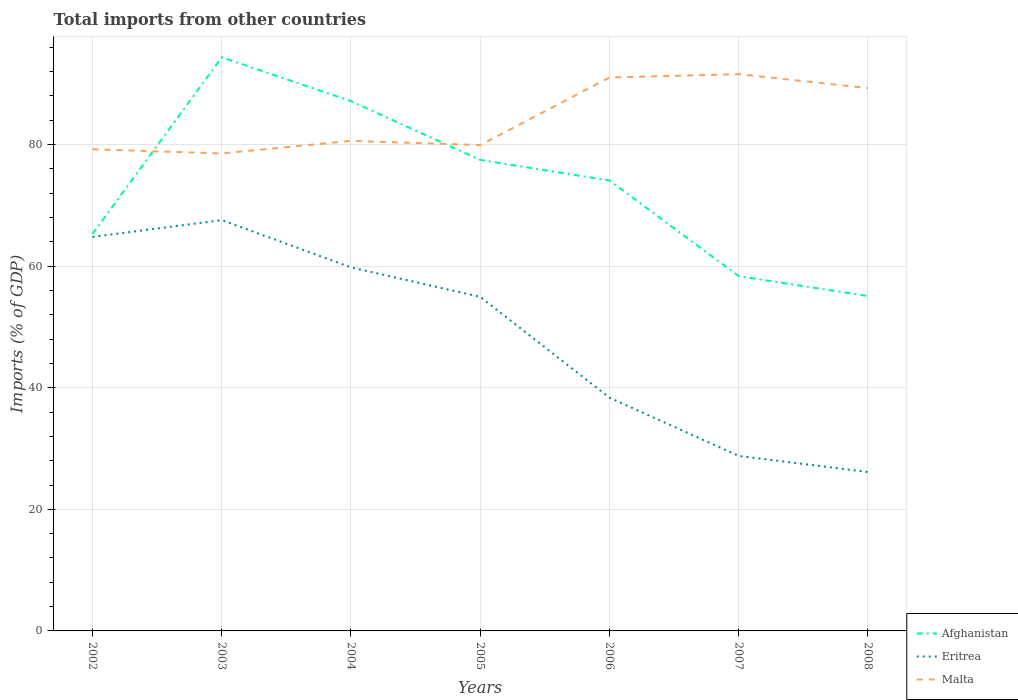How many different coloured lines are there?
Ensure brevity in your answer.  3. Does the line corresponding to Malta intersect with the line corresponding to Afghanistan?
Make the answer very short. Yes. Is the number of lines equal to the number of legend labels?
Give a very brief answer. Yes. Across all years, what is the maximum total imports in Afghanistan?
Provide a short and direct response. 55.07. What is the total total imports in Malta in the graph?
Your response must be concise. -1.37. What is the difference between the highest and the second highest total imports in Eritrea?
Offer a very short reply. 41.43. What is the difference between the highest and the lowest total imports in Malta?
Provide a short and direct response. 3. Is the total imports in Afghanistan strictly greater than the total imports in Eritrea over the years?
Keep it short and to the point. No. What is the difference between two consecutive major ticks on the Y-axis?
Your answer should be compact. 20. Are the values on the major ticks of Y-axis written in scientific E-notation?
Keep it short and to the point. No. Does the graph contain any zero values?
Your answer should be compact. No. Where does the legend appear in the graph?
Give a very brief answer. Bottom right. How many legend labels are there?
Provide a succinct answer. 3. What is the title of the graph?
Give a very brief answer. Total imports from other countries. Does "Zambia" appear as one of the legend labels in the graph?
Give a very brief answer. No. What is the label or title of the X-axis?
Your answer should be compact. Years. What is the label or title of the Y-axis?
Give a very brief answer. Imports (% of GDP). What is the Imports (% of GDP) in Afghanistan in 2002?
Your response must be concise. 65.29. What is the Imports (% of GDP) of Eritrea in 2002?
Provide a succinct answer. 64.81. What is the Imports (% of GDP) of Malta in 2002?
Give a very brief answer. 79.22. What is the Imports (% of GDP) in Afghanistan in 2003?
Provide a succinct answer. 94.34. What is the Imports (% of GDP) in Eritrea in 2003?
Your answer should be very brief. 67.57. What is the Imports (% of GDP) of Malta in 2003?
Provide a succinct answer. 78.53. What is the Imports (% of GDP) in Afghanistan in 2004?
Your answer should be very brief. 87.14. What is the Imports (% of GDP) in Eritrea in 2004?
Ensure brevity in your answer.  59.8. What is the Imports (% of GDP) in Malta in 2004?
Your answer should be very brief. 80.6. What is the Imports (% of GDP) in Afghanistan in 2005?
Your answer should be very brief. 77.47. What is the Imports (% of GDP) of Eritrea in 2005?
Ensure brevity in your answer.  54.94. What is the Imports (% of GDP) of Malta in 2005?
Offer a terse response. 79.91. What is the Imports (% of GDP) in Afghanistan in 2006?
Offer a terse response. 74.09. What is the Imports (% of GDP) in Eritrea in 2006?
Provide a succinct answer. 38.36. What is the Imports (% of GDP) of Malta in 2006?
Offer a terse response. 91.02. What is the Imports (% of GDP) in Afghanistan in 2007?
Your response must be concise. 58.35. What is the Imports (% of GDP) in Eritrea in 2007?
Keep it short and to the point. 28.79. What is the Imports (% of GDP) of Malta in 2007?
Provide a succinct answer. 91.57. What is the Imports (% of GDP) of Afghanistan in 2008?
Provide a succinct answer. 55.07. What is the Imports (% of GDP) in Eritrea in 2008?
Your answer should be compact. 26.13. What is the Imports (% of GDP) of Malta in 2008?
Offer a terse response. 89.28. Across all years, what is the maximum Imports (% of GDP) of Afghanistan?
Offer a terse response. 94.34. Across all years, what is the maximum Imports (% of GDP) of Eritrea?
Offer a very short reply. 67.57. Across all years, what is the maximum Imports (% of GDP) in Malta?
Keep it short and to the point. 91.57. Across all years, what is the minimum Imports (% of GDP) of Afghanistan?
Your answer should be very brief. 55.07. Across all years, what is the minimum Imports (% of GDP) in Eritrea?
Your answer should be very brief. 26.13. Across all years, what is the minimum Imports (% of GDP) of Malta?
Keep it short and to the point. 78.53. What is the total Imports (% of GDP) of Afghanistan in the graph?
Offer a terse response. 511.75. What is the total Imports (% of GDP) in Eritrea in the graph?
Your answer should be compact. 340.39. What is the total Imports (% of GDP) in Malta in the graph?
Offer a very short reply. 590.14. What is the difference between the Imports (% of GDP) in Afghanistan in 2002 and that in 2003?
Your response must be concise. -29.06. What is the difference between the Imports (% of GDP) of Eritrea in 2002 and that in 2003?
Ensure brevity in your answer.  -2.76. What is the difference between the Imports (% of GDP) of Malta in 2002 and that in 2003?
Your answer should be very brief. 0.69. What is the difference between the Imports (% of GDP) of Afghanistan in 2002 and that in 2004?
Keep it short and to the point. -21.85. What is the difference between the Imports (% of GDP) of Eritrea in 2002 and that in 2004?
Provide a short and direct response. 5.01. What is the difference between the Imports (% of GDP) of Malta in 2002 and that in 2004?
Keep it short and to the point. -1.38. What is the difference between the Imports (% of GDP) of Afghanistan in 2002 and that in 2005?
Provide a short and direct response. -12.18. What is the difference between the Imports (% of GDP) in Eritrea in 2002 and that in 2005?
Ensure brevity in your answer.  9.87. What is the difference between the Imports (% of GDP) in Malta in 2002 and that in 2005?
Your answer should be very brief. -0.69. What is the difference between the Imports (% of GDP) in Afghanistan in 2002 and that in 2006?
Provide a short and direct response. -8.8. What is the difference between the Imports (% of GDP) in Eritrea in 2002 and that in 2006?
Provide a succinct answer. 26.45. What is the difference between the Imports (% of GDP) of Malta in 2002 and that in 2006?
Ensure brevity in your answer.  -11.8. What is the difference between the Imports (% of GDP) in Afghanistan in 2002 and that in 2007?
Offer a very short reply. 6.94. What is the difference between the Imports (% of GDP) of Eritrea in 2002 and that in 2007?
Ensure brevity in your answer.  36.02. What is the difference between the Imports (% of GDP) in Malta in 2002 and that in 2007?
Give a very brief answer. -12.35. What is the difference between the Imports (% of GDP) of Afghanistan in 2002 and that in 2008?
Keep it short and to the point. 10.22. What is the difference between the Imports (% of GDP) of Eritrea in 2002 and that in 2008?
Provide a short and direct response. 38.68. What is the difference between the Imports (% of GDP) of Malta in 2002 and that in 2008?
Provide a short and direct response. -10.06. What is the difference between the Imports (% of GDP) of Afghanistan in 2003 and that in 2004?
Your response must be concise. 7.2. What is the difference between the Imports (% of GDP) in Eritrea in 2003 and that in 2004?
Offer a very short reply. 7.77. What is the difference between the Imports (% of GDP) of Malta in 2003 and that in 2004?
Ensure brevity in your answer.  -2.07. What is the difference between the Imports (% of GDP) of Afghanistan in 2003 and that in 2005?
Offer a terse response. 16.88. What is the difference between the Imports (% of GDP) of Eritrea in 2003 and that in 2005?
Make the answer very short. 12.63. What is the difference between the Imports (% of GDP) of Malta in 2003 and that in 2005?
Keep it short and to the point. -1.37. What is the difference between the Imports (% of GDP) in Afghanistan in 2003 and that in 2006?
Your response must be concise. 20.26. What is the difference between the Imports (% of GDP) of Eritrea in 2003 and that in 2006?
Keep it short and to the point. 29.2. What is the difference between the Imports (% of GDP) in Malta in 2003 and that in 2006?
Offer a terse response. -12.49. What is the difference between the Imports (% of GDP) in Afghanistan in 2003 and that in 2007?
Your answer should be very brief. 35.99. What is the difference between the Imports (% of GDP) of Eritrea in 2003 and that in 2007?
Provide a succinct answer. 38.78. What is the difference between the Imports (% of GDP) of Malta in 2003 and that in 2007?
Your response must be concise. -13.04. What is the difference between the Imports (% of GDP) in Afghanistan in 2003 and that in 2008?
Your answer should be compact. 39.27. What is the difference between the Imports (% of GDP) of Eritrea in 2003 and that in 2008?
Your response must be concise. 41.43. What is the difference between the Imports (% of GDP) in Malta in 2003 and that in 2008?
Offer a very short reply. -10.75. What is the difference between the Imports (% of GDP) of Afghanistan in 2004 and that in 2005?
Make the answer very short. 9.67. What is the difference between the Imports (% of GDP) of Eritrea in 2004 and that in 2005?
Your answer should be very brief. 4.86. What is the difference between the Imports (% of GDP) of Malta in 2004 and that in 2005?
Keep it short and to the point. 0.69. What is the difference between the Imports (% of GDP) in Afghanistan in 2004 and that in 2006?
Your response must be concise. 13.05. What is the difference between the Imports (% of GDP) in Eritrea in 2004 and that in 2006?
Make the answer very short. 21.43. What is the difference between the Imports (% of GDP) in Malta in 2004 and that in 2006?
Your response must be concise. -10.42. What is the difference between the Imports (% of GDP) of Afghanistan in 2004 and that in 2007?
Keep it short and to the point. 28.79. What is the difference between the Imports (% of GDP) of Eritrea in 2004 and that in 2007?
Keep it short and to the point. 31.01. What is the difference between the Imports (% of GDP) of Malta in 2004 and that in 2007?
Ensure brevity in your answer.  -10.97. What is the difference between the Imports (% of GDP) in Afghanistan in 2004 and that in 2008?
Offer a terse response. 32.07. What is the difference between the Imports (% of GDP) of Eritrea in 2004 and that in 2008?
Make the answer very short. 33.66. What is the difference between the Imports (% of GDP) in Malta in 2004 and that in 2008?
Offer a very short reply. -8.68. What is the difference between the Imports (% of GDP) of Afghanistan in 2005 and that in 2006?
Keep it short and to the point. 3.38. What is the difference between the Imports (% of GDP) of Eritrea in 2005 and that in 2006?
Give a very brief answer. 16.58. What is the difference between the Imports (% of GDP) of Malta in 2005 and that in 2006?
Offer a very short reply. -11.11. What is the difference between the Imports (% of GDP) in Afghanistan in 2005 and that in 2007?
Your answer should be very brief. 19.12. What is the difference between the Imports (% of GDP) in Eritrea in 2005 and that in 2007?
Ensure brevity in your answer.  26.15. What is the difference between the Imports (% of GDP) in Malta in 2005 and that in 2007?
Offer a very short reply. -11.67. What is the difference between the Imports (% of GDP) of Afghanistan in 2005 and that in 2008?
Your answer should be compact. 22.39. What is the difference between the Imports (% of GDP) of Eritrea in 2005 and that in 2008?
Give a very brief answer. 28.81. What is the difference between the Imports (% of GDP) of Malta in 2005 and that in 2008?
Give a very brief answer. -9.37. What is the difference between the Imports (% of GDP) in Afghanistan in 2006 and that in 2007?
Offer a very short reply. 15.73. What is the difference between the Imports (% of GDP) in Eritrea in 2006 and that in 2007?
Your answer should be compact. 9.57. What is the difference between the Imports (% of GDP) of Malta in 2006 and that in 2007?
Offer a very short reply. -0.55. What is the difference between the Imports (% of GDP) in Afghanistan in 2006 and that in 2008?
Provide a short and direct response. 19.01. What is the difference between the Imports (% of GDP) of Eritrea in 2006 and that in 2008?
Keep it short and to the point. 12.23. What is the difference between the Imports (% of GDP) of Malta in 2006 and that in 2008?
Your answer should be very brief. 1.74. What is the difference between the Imports (% of GDP) of Afghanistan in 2007 and that in 2008?
Give a very brief answer. 3.28. What is the difference between the Imports (% of GDP) of Eritrea in 2007 and that in 2008?
Give a very brief answer. 2.66. What is the difference between the Imports (% of GDP) in Malta in 2007 and that in 2008?
Your response must be concise. 2.29. What is the difference between the Imports (% of GDP) in Afghanistan in 2002 and the Imports (% of GDP) in Eritrea in 2003?
Give a very brief answer. -2.28. What is the difference between the Imports (% of GDP) in Afghanistan in 2002 and the Imports (% of GDP) in Malta in 2003?
Give a very brief answer. -13.25. What is the difference between the Imports (% of GDP) of Eritrea in 2002 and the Imports (% of GDP) of Malta in 2003?
Provide a short and direct response. -13.72. What is the difference between the Imports (% of GDP) in Afghanistan in 2002 and the Imports (% of GDP) in Eritrea in 2004?
Make the answer very short. 5.49. What is the difference between the Imports (% of GDP) of Afghanistan in 2002 and the Imports (% of GDP) of Malta in 2004?
Provide a short and direct response. -15.31. What is the difference between the Imports (% of GDP) of Eritrea in 2002 and the Imports (% of GDP) of Malta in 2004?
Your answer should be very brief. -15.79. What is the difference between the Imports (% of GDP) of Afghanistan in 2002 and the Imports (% of GDP) of Eritrea in 2005?
Offer a terse response. 10.35. What is the difference between the Imports (% of GDP) of Afghanistan in 2002 and the Imports (% of GDP) of Malta in 2005?
Ensure brevity in your answer.  -14.62. What is the difference between the Imports (% of GDP) in Eritrea in 2002 and the Imports (% of GDP) in Malta in 2005?
Offer a very short reply. -15.1. What is the difference between the Imports (% of GDP) in Afghanistan in 2002 and the Imports (% of GDP) in Eritrea in 2006?
Your answer should be very brief. 26.93. What is the difference between the Imports (% of GDP) in Afghanistan in 2002 and the Imports (% of GDP) in Malta in 2006?
Offer a very short reply. -25.73. What is the difference between the Imports (% of GDP) of Eritrea in 2002 and the Imports (% of GDP) of Malta in 2006?
Provide a succinct answer. -26.21. What is the difference between the Imports (% of GDP) of Afghanistan in 2002 and the Imports (% of GDP) of Eritrea in 2007?
Provide a succinct answer. 36.5. What is the difference between the Imports (% of GDP) in Afghanistan in 2002 and the Imports (% of GDP) in Malta in 2007?
Your response must be concise. -26.29. What is the difference between the Imports (% of GDP) in Eritrea in 2002 and the Imports (% of GDP) in Malta in 2007?
Ensure brevity in your answer.  -26.77. What is the difference between the Imports (% of GDP) in Afghanistan in 2002 and the Imports (% of GDP) in Eritrea in 2008?
Your answer should be very brief. 39.16. What is the difference between the Imports (% of GDP) in Afghanistan in 2002 and the Imports (% of GDP) in Malta in 2008?
Offer a terse response. -23.99. What is the difference between the Imports (% of GDP) in Eritrea in 2002 and the Imports (% of GDP) in Malta in 2008?
Keep it short and to the point. -24.47. What is the difference between the Imports (% of GDP) in Afghanistan in 2003 and the Imports (% of GDP) in Eritrea in 2004?
Keep it short and to the point. 34.55. What is the difference between the Imports (% of GDP) in Afghanistan in 2003 and the Imports (% of GDP) in Malta in 2004?
Your answer should be very brief. 13.74. What is the difference between the Imports (% of GDP) of Eritrea in 2003 and the Imports (% of GDP) of Malta in 2004?
Your answer should be compact. -13.03. What is the difference between the Imports (% of GDP) of Afghanistan in 2003 and the Imports (% of GDP) of Eritrea in 2005?
Make the answer very short. 39.4. What is the difference between the Imports (% of GDP) of Afghanistan in 2003 and the Imports (% of GDP) of Malta in 2005?
Make the answer very short. 14.44. What is the difference between the Imports (% of GDP) in Eritrea in 2003 and the Imports (% of GDP) in Malta in 2005?
Offer a terse response. -12.34. What is the difference between the Imports (% of GDP) in Afghanistan in 2003 and the Imports (% of GDP) in Eritrea in 2006?
Provide a succinct answer. 55.98. What is the difference between the Imports (% of GDP) in Afghanistan in 2003 and the Imports (% of GDP) in Malta in 2006?
Keep it short and to the point. 3.32. What is the difference between the Imports (% of GDP) in Eritrea in 2003 and the Imports (% of GDP) in Malta in 2006?
Provide a short and direct response. -23.46. What is the difference between the Imports (% of GDP) of Afghanistan in 2003 and the Imports (% of GDP) of Eritrea in 2007?
Your response must be concise. 65.56. What is the difference between the Imports (% of GDP) of Afghanistan in 2003 and the Imports (% of GDP) of Malta in 2007?
Give a very brief answer. 2.77. What is the difference between the Imports (% of GDP) in Eritrea in 2003 and the Imports (% of GDP) in Malta in 2007?
Keep it short and to the point. -24.01. What is the difference between the Imports (% of GDP) in Afghanistan in 2003 and the Imports (% of GDP) in Eritrea in 2008?
Offer a very short reply. 68.21. What is the difference between the Imports (% of GDP) in Afghanistan in 2003 and the Imports (% of GDP) in Malta in 2008?
Offer a very short reply. 5.06. What is the difference between the Imports (% of GDP) of Eritrea in 2003 and the Imports (% of GDP) of Malta in 2008?
Provide a short and direct response. -21.71. What is the difference between the Imports (% of GDP) of Afghanistan in 2004 and the Imports (% of GDP) of Eritrea in 2005?
Offer a very short reply. 32.2. What is the difference between the Imports (% of GDP) in Afghanistan in 2004 and the Imports (% of GDP) in Malta in 2005?
Your answer should be compact. 7.23. What is the difference between the Imports (% of GDP) in Eritrea in 2004 and the Imports (% of GDP) in Malta in 2005?
Provide a short and direct response. -20.11. What is the difference between the Imports (% of GDP) in Afghanistan in 2004 and the Imports (% of GDP) in Eritrea in 2006?
Your answer should be very brief. 48.78. What is the difference between the Imports (% of GDP) of Afghanistan in 2004 and the Imports (% of GDP) of Malta in 2006?
Offer a very short reply. -3.88. What is the difference between the Imports (% of GDP) of Eritrea in 2004 and the Imports (% of GDP) of Malta in 2006?
Your answer should be compact. -31.23. What is the difference between the Imports (% of GDP) in Afghanistan in 2004 and the Imports (% of GDP) in Eritrea in 2007?
Make the answer very short. 58.35. What is the difference between the Imports (% of GDP) in Afghanistan in 2004 and the Imports (% of GDP) in Malta in 2007?
Offer a terse response. -4.44. What is the difference between the Imports (% of GDP) of Eritrea in 2004 and the Imports (% of GDP) of Malta in 2007?
Give a very brief answer. -31.78. What is the difference between the Imports (% of GDP) of Afghanistan in 2004 and the Imports (% of GDP) of Eritrea in 2008?
Your answer should be compact. 61.01. What is the difference between the Imports (% of GDP) in Afghanistan in 2004 and the Imports (% of GDP) in Malta in 2008?
Offer a very short reply. -2.14. What is the difference between the Imports (% of GDP) in Eritrea in 2004 and the Imports (% of GDP) in Malta in 2008?
Keep it short and to the point. -29.48. What is the difference between the Imports (% of GDP) of Afghanistan in 2005 and the Imports (% of GDP) of Eritrea in 2006?
Make the answer very short. 39.11. What is the difference between the Imports (% of GDP) in Afghanistan in 2005 and the Imports (% of GDP) in Malta in 2006?
Keep it short and to the point. -13.55. What is the difference between the Imports (% of GDP) in Eritrea in 2005 and the Imports (% of GDP) in Malta in 2006?
Offer a very short reply. -36.08. What is the difference between the Imports (% of GDP) in Afghanistan in 2005 and the Imports (% of GDP) in Eritrea in 2007?
Keep it short and to the point. 48.68. What is the difference between the Imports (% of GDP) of Afghanistan in 2005 and the Imports (% of GDP) of Malta in 2007?
Your response must be concise. -14.11. What is the difference between the Imports (% of GDP) of Eritrea in 2005 and the Imports (% of GDP) of Malta in 2007?
Make the answer very short. -36.63. What is the difference between the Imports (% of GDP) in Afghanistan in 2005 and the Imports (% of GDP) in Eritrea in 2008?
Offer a very short reply. 51.34. What is the difference between the Imports (% of GDP) of Afghanistan in 2005 and the Imports (% of GDP) of Malta in 2008?
Provide a succinct answer. -11.81. What is the difference between the Imports (% of GDP) of Eritrea in 2005 and the Imports (% of GDP) of Malta in 2008?
Your answer should be compact. -34.34. What is the difference between the Imports (% of GDP) of Afghanistan in 2006 and the Imports (% of GDP) of Eritrea in 2007?
Your response must be concise. 45.3. What is the difference between the Imports (% of GDP) in Afghanistan in 2006 and the Imports (% of GDP) in Malta in 2007?
Offer a very short reply. -17.49. What is the difference between the Imports (% of GDP) of Eritrea in 2006 and the Imports (% of GDP) of Malta in 2007?
Keep it short and to the point. -53.21. What is the difference between the Imports (% of GDP) in Afghanistan in 2006 and the Imports (% of GDP) in Eritrea in 2008?
Keep it short and to the point. 47.95. What is the difference between the Imports (% of GDP) of Afghanistan in 2006 and the Imports (% of GDP) of Malta in 2008?
Your answer should be compact. -15.2. What is the difference between the Imports (% of GDP) of Eritrea in 2006 and the Imports (% of GDP) of Malta in 2008?
Provide a short and direct response. -50.92. What is the difference between the Imports (% of GDP) in Afghanistan in 2007 and the Imports (% of GDP) in Eritrea in 2008?
Make the answer very short. 32.22. What is the difference between the Imports (% of GDP) of Afghanistan in 2007 and the Imports (% of GDP) of Malta in 2008?
Keep it short and to the point. -30.93. What is the difference between the Imports (% of GDP) of Eritrea in 2007 and the Imports (% of GDP) of Malta in 2008?
Provide a succinct answer. -60.49. What is the average Imports (% of GDP) in Afghanistan per year?
Ensure brevity in your answer.  73.11. What is the average Imports (% of GDP) in Eritrea per year?
Your answer should be compact. 48.63. What is the average Imports (% of GDP) in Malta per year?
Ensure brevity in your answer.  84.31. In the year 2002, what is the difference between the Imports (% of GDP) of Afghanistan and Imports (% of GDP) of Eritrea?
Make the answer very short. 0.48. In the year 2002, what is the difference between the Imports (% of GDP) of Afghanistan and Imports (% of GDP) of Malta?
Offer a very short reply. -13.93. In the year 2002, what is the difference between the Imports (% of GDP) of Eritrea and Imports (% of GDP) of Malta?
Provide a short and direct response. -14.41. In the year 2003, what is the difference between the Imports (% of GDP) of Afghanistan and Imports (% of GDP) of Eritrea?
Your answer should be compact. 26.78. In the year 2003, what is the difference between the Imports (% of GDP) in Afghanistan and Imports (% of GDP) in Malta?
Provide a short and direct response. 15.81. In the year 2003, what is the difference between the Imports (% of GDP) of Eritrea and Imports (% of GDP) of Malta?
Your answer should be very brief. -10.97. In the year 2004, what is the difference between the Imports (% of GDP) of Afghanistan and Imports (% of GDP) of Eritrea?
Keep it short and to the point. 27.34. In the year 2004, what is the difference between the Imports (% of GDP) in Afghanistan and Imports (% of GDP) in Malta?
Offer a terse response. 6.54. In the year 2004, what is the difference between the Imports (% of GDP) in Eritrea and Imports (% of GDP) in Malta?
Your answer should be very brief. -20.8. In the year 2005, what is the difference between the Imports (% of GDP) in Afghanistan and Imports (% of GDP) in Eritrea?
Make the answer very short. 22.53. In the year 2005, what is the difference between the Imports (% of GDP) of Afghanistan and Imports (% of GDP) of Malta?
Ensure brevity in your answer.  -2.44. In the year 2005, what is the difference between the Imports (% of GDP) in Eritrea and Imports (% of GDP) in Malta?
Your answer should be very brief. -24.97. In the year 2006, what is the difference between the Imports (% of GDP) in Afghanistan and Imports (% of GDP) in Eritrea?
Keep it short and to the point. 35.72. In the year 2006, what is the difference between the Imports (% of GDP) in Afghanistan and Imports (% of GDP) in Malta?
Offer a very short reply. -16.94. In the year 2006, what is the difference between the Imports (% of GDP) of Eritrea and Imports (% of GDP) of Malta?
Your response must be concise. -52.66. In the year 2007, what is the difference between the Imports (% of GDP) in Afghanistan and Imports (% of GDP) in Eritrea?
Ensure brevity in your answer.  29.56. In the year 2007, what is the difference between the Imports (% of GDP) in Afghanistan and Imports (% of GDP) in Malta?
Your response must be concise. -33.22. In the year 2007, what is the difference between the Imports (% of GDP) in Eritrea and Imports (% of GDP) in Malta?
Make the answer very short. -62.79. In the year 2008, what is the difference between the Imports (% of GDP) in Afghanistan and Imports (% of GDP) in Eritrea?
Your response must be concise. 28.94. In the year 2008, what is the difference between the Imports (% of GDP) in Afghanistan and Imports (% of GDP) in Malta?
Your response must be concise. -34.21. In the year 2008, what is the difference between the Imports (% of GDP) in Eritrea and Imports (% of GDP) in Malta?
Your answer should be compact. -63.15. What is the ratio of the Imports (% of GDP) in Afghanistan in 2002 to that in 2003?
Offer a very short reply. 0.69. What is the ratio of the Imports (% of GDP) in Eritrea in 2002 to that in 2003?
Provide a short and direct response. 0.96. What is the ratio of the Imports (% of GDP) in Malta in 2002 to that in 2003?
Provide a short and direct response. 1.01. What is the ratio of the Imports (% of GDP) of Afghanistan in 2002 to that in 2004?
Your answer should be compact. 0.75. What is the ratio of the Imports (% of GDP) of Eritrea in 2002 to that in 2004?
Your response must be concise. 1.08. What is the ratio of the Imports (% of GDP) in Malta in 2002 to that in 2004?
Offer a terse response. 0.98. What is the ratio of the Imports (% of GDP) of Afghanistan in 2002 to that in 2005?
Give a very brief answer. 0.84. What is the ratio of the Imports (% of GDP) of Eritrea in 2002 to that in 2005?
Offer a terse response. 1.18. What is the ratio of the Imports (% of GDP) of Malta in 2002 to that in 2005?
Your response must be concise. 0.99. What is the ratio of the Imports (% of GDP) of Afghanistan in 2002 to that in 2006?
Offer a very short reply. 0.88. What is the ratio of the Imports (% of GDP) of Eritrea in 2002 to that in 2006?
Offer a terse response. 1.69. What is the ratio of the Imports (% of GDP) of Malta in 2002 to that in 2006?
Your answer should be very brief. 0.87. What is the ratio of the Imports (% of GDP) in Afghanistan in 2002 to that in 2007?
Keep it short and to the point. 1.12. What is the ratio of the Imports (% of GDP) in Eritrea in 2002 to that in 2007?
Make the answer very short. 2.25. What is the ratio of the Imports (% of GDP) of Malta in 2002 to that in 2007?
Provide a succinct answer. 0.87. What is the ratio of the Imports (% of GDP) of Afghanistan in 2002 to that in 2008?
Provide a succinct answer. 1.19. What is the ratio of the Imports (% of GDP) in Eritrea in 2002 to that in 2008?
Offer a terse response. 2.48. What is the ratio of the Imports (% of GDP) in Malta in 2002 to that in 2008?
Ensure brevity in your answer.  0.89. What is the ratio of the Imports (% of GDP) of Afghanistan in 2003 to that in 2004?
Keep it short and to the point. 1.08. What is the ratio of the Imports (% of GDP) in Eritrea in 2003 to that in 2004?
Give a very brief answer. 1.13. What is the ratio of the Imports (% of GDP) of Malta in 2003 to that in 2004?
Your answer should be very brief. 0.97. What is the ratio of the Imports (% of GDP) of Afghanistan in 2003 to that in 2005?
Offer a terse response. 1.22. What is the ratio of the Imports (% of GDP) of Eritrea in 2003 to that in 2005?
Provide a short and direct response. 1.23. What is the ratio of the Imports (% of GDP) in Malta in 2003 to that in 2005?
Keep it short and to the point. 0.98. What is the ratio of the Imports (% of GDP) in Afghanistan in 2003 to that in 2006?
Offer a terse response. 1.27. What is the ratio of the Imports (% of GDP) of Eritrea in 2003 to that in 2006?
Your answer should be very brief. 1.76. What is the ratio of the Imports (% of GDP) of Malta in 2003 to that in 2006?
Keep it short and to the point. 0.86. What is the ratio of the Imports (% of GDP) in Afghanistan in 2003 to that in 2007?
Give a very brief answer. 1.62. What is the ratio of the Imports (% of GDP) in Eritrea in 2003 to that in 2007?
Offer a very short reply. 2.35. What is the ratio of the Imports (% of GDP) in Malta in 2003 to that in 2007?
Your response must be concise. 0.86. What is the ratio of the Imports (% of GDP) of Afghanistan in 2003 to that in 2008?
Your response must be concise. 1.71. What is the ratio of the Imports (% of GDP) in Eritrea in 2003 to that in 2008?
Ensure brevity in your answer.  2.59. What is the ratio of the Imports (% of GDP) of Malta in 2003 to that in 2008?
Offer a very short reply. 0.88. What is the ratio of the Imports (% of GDP) in Afghanistan in 2004 to that in 2005?
Give a very brief answer. 1.12. What is the ratio of the Imports (% of GDP) of Eritrea in 2004 to that in 2005?
Offer a terse response. 1.09. What is the ratio of the Imports (% of GDP) in Malta in 2004 to that in 2005?
Give a very brief answer. 1.01. What is the ratio of the Imports (% of GDP) of Afghanistan in 2004 to that in 2006?
Ensure brevity in your answer.  1.18. What is the ratio of the Imports (% of GDP) in Eritrea in 2004 to that in 2006?
Your response must be concise. 1.56. What is the ratio of the Imports (% of GDP) of Malta in 2004 to that in 2006?
Give a very brief answer. 0.89. What is the ratio of the Imports (% of GDP) in Afghanistan in 2004 to that in 2007?
Give a very brief answer. 1.49. What is the ratio of the Imports (% of GDP) in Eritrea in 2004 to that in 2007?
Offer a terse response. 2.08. What is the ratio of the Imports (% of GDP) in Malta in 2004 to that in 2007?
Your response must be concise. 0.88. What is the ratio of the Imports (% of GDP) in Afghanistan in 2004 to that in 2008?
Your answer should be compact. 1.58. What is the ratio of the Imports (% of GDP) in Eritrea in 2004 to that in 2008?
Provide a succinct answer. 2.29. What is the ratio of the Imports (% of GDP) of Malta in 2004 to that in 2008?
Provide a short and direct response. 0.9. What is the ratio of the Imports (% of GDP) of Afghanistan in 2005 to that in 2006?
Your answer should be compact. 1.05. What is the ratio of the Imports (% of GDP) in Eritrea in 2005 to that in 2006?
Offer a very short reply. 1.43. What is the ratio of the Imports (% of GDP) in Malta in 2005 to that in 2006?
Your answer should be compact. 0.88. What is the ratio of the Imports (% of GDP) in Afghanistan in 2005 to that in 2007?
Ensure brevity in your answer.  1.33. What is the ratio of the Imports (% of GDP) in Eritrea in 2005 to that in 2007?
Provide a short and direct response. 1.91. What is the ratio of the Imports (% of GDP) in Malta in 2005 to that in 2007?
Give a very brief answer. 0.87. What is the ratio of the Imports (% of GDP) in Afghanistan in 2005 to that in 2008?
Your answer should be very brief. 1.41. What is the ratio of the Imports (% of GDP) of Eritrea in 2005 to that in 2008?
Give a very brief answer. 2.1. What is the ratio of the Imports (% of GDP) in Malta in 2005 to that in 2008?
Make the answer very short. 0.9. What is the ratio of the Imports (% of GDP) in Afghanistan in 2006 to that in 2007?
Give a very brief answer. 1.27. What is the ratio of the Imports (% of GDP) in Eritrea in 2006 to that in 2007?
Provide a succinct answer. 1.33. What is the ratio of the Imports (% of GDP) of Malta in 2006 to that in 2007?
Give a very brief answer. 0.99. What is the ratio of the Imports (% of GDP) in Afghanistan in 2006 to that in 2008?
Make the answer very short. 1.35. What is the ratio of the Imports (% of GDP) of Eritrea in 2006 to that in 2008?
Offer a terse response. 1.47. What is the ratio of the Imports (% of GDP) of Malta in 2006 to that in 2008?
Your answer should be compact. 1.02. What is the ratio of the Imports (% of GDP) of Afghanistan in 2007 to that in 2008?
Your answer should be very brief. 1.06. What is the ratio of the Imports (% of GDP) in Eritrea in 2007 to that in 2008?
Provide a succinct answer. 1.1. What is the ratio of the Imports (% of GDP) of Malta in 2007 to that in 2008?
Make the answer very short. 1.03. What is the difference between the highest and the second highest Imports (% of GDP) of Afghanistan?
Provide a short and direct response. 7.2. What is the difference between the highest and the second highest Imports (% of GDP) of Eritrea?
Provide a short and direct response. 2.76. What is the difference between the highest and the second highest Imports (% of GDP) in Malta?
Give a very brief answer. 0.55. What is the difference between the highest and the lowest Imports (% of GDP) of Afghanistan?
Give a very brief answer. 39.27. What is the difference between the highest and the lowest Imports (% of GDP) in Eritrea?
Your response must be concise. 41.43. What is the difference between the highest and the lowest Imports (% of GDP) in Malta?
Ensure brevity in your answer.  13.04. 